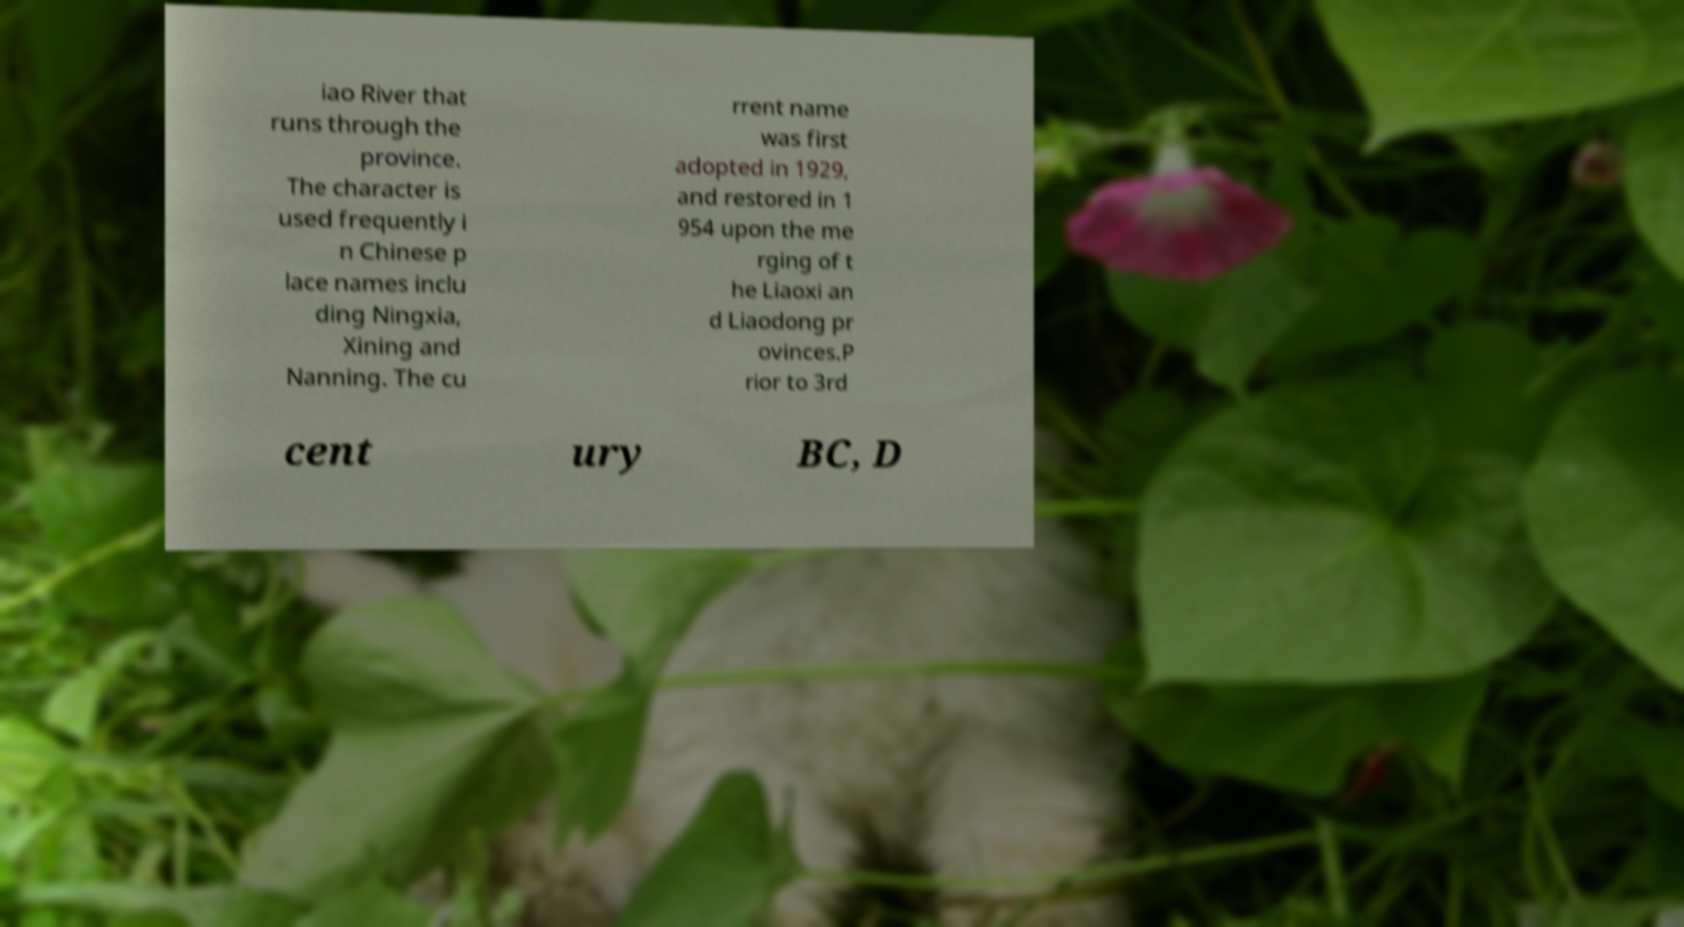Please read and relay the text visible in this image. What does it say? iao River that runs through the province. The character is used frequently i n Chinese p lace names inclu ding Ningxia, Xining and Nanning. The cu rrent name was first adopted in 1929, and restored in 1 954 upon the me rging of t he Liaoxi an d Liaodong pr ovinces.P rior to 3rd cent ury BC, D 